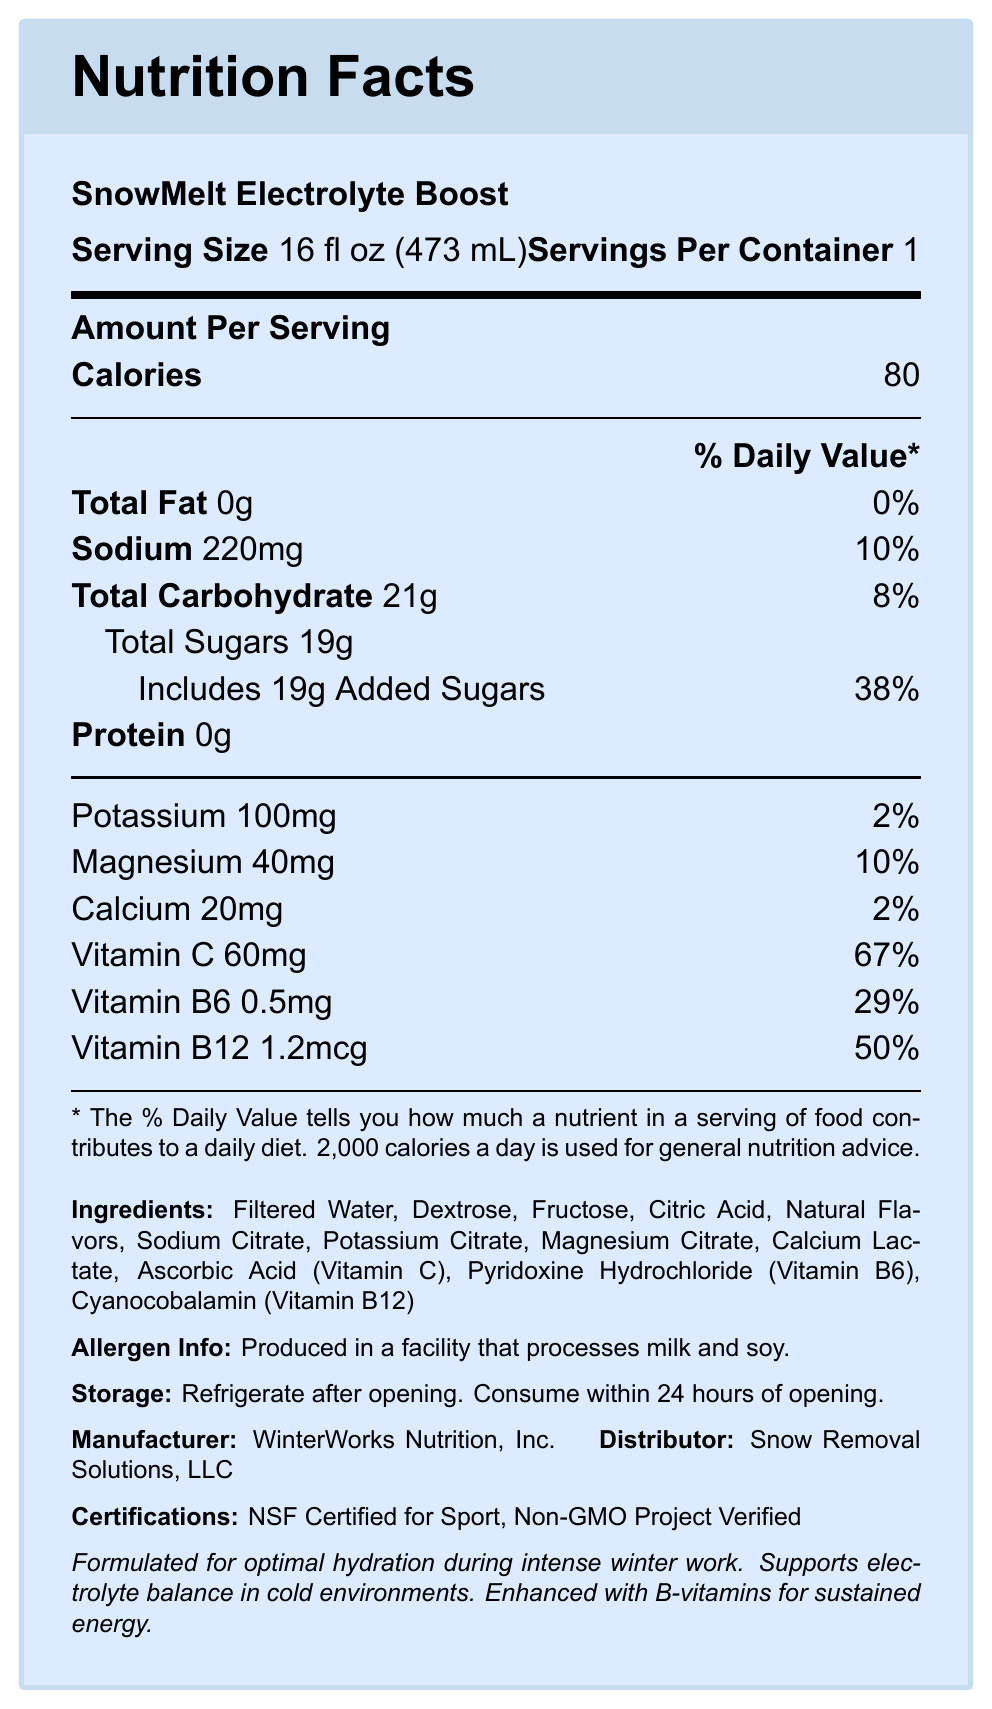What is the serving size of SnowMelt Electrolyte Boost? The document specifies the serving size clearly at the top.
Answer: 16 fl oz (473 mL) How many calories are in one serving? The calories per serving are listed under the "Amount Per Serving" section.
Answer: 80 calories What is the % Daily Value of sodium per serving? The % Daily Value of sodium is given in the same row as the sodium amount, which is 220mg and 10%.
Answer: 10% Which ingredient provides Vitamin C in the drink? The list of ingredients includes Ascorbic Acid which is known as Vitamin C.
Answer: Ascorbic Acid Should the product be refrigerated after opening? The document contains storage instructions specifying to refrigerate after opening.
Answer: Yes How many grams of total sugar does one serving contain? The amount of total sugars per serving is stated as 19g in the nutritional facts.
Answer: 19g What potential allergens might be present due to the processing facility? A. Nuts B. Milk and Soy C. Gluten D. Eggs The allergen information specifies that the product is made in a facility that processes milk and soy.
Answer: B. Milk and Soy Which of the following vitamins is NOT included in the drink? I. Vitamin A II. Vitamin C III. Vitamin B6 IV. Vitamin B12 The nutritional facts label lists Vitamin C, Vitamin B6, and Vitamin B12, but does not include Vitamin A.
Answer: I. Vitamin A Does the drink provide any protein per serving? The nutritional facts state that the protein amount per serving is 0g.
Answer: No Summarize the nutrition and beneficial components of this sports drink. The drink is particularly formulated to support electrolyte balance and sustained energy in cold environments, beneficial for snow removal crews.
Answer: SnowMelt Electrolyte Boost is designed for optimal hydration during intense winter work. A 16 fl oz serving contains 80 calories, 0g of fat, 220mg of sodium (10% DV), 21g of carbohydrates (8% DV), 19g of sugars (including 19g added sugars comprising 38% DV), 100mg of potassium (2% DV), 40mg of magnesium (10% DV), 20mg of calcium (2% DV), 60mg of Vitamin C (67% DV), 0.5mg of Vitamin B6 (29% DV), and 1.2mcg of Vitamin B12 (50% DV). It is NSF Certified for Sport and Non-GMO Project Verified. Ingredients include filtered water, dextrose, and a range of vitamins and minerals. The drink should be refrigerated after opening and consumed within 24 hours. Is this product certified for use in sports? The document indicates that the product is NSF Certified for Sport.
Answer: Yes What is the role of B-vitamins in this drink according to the additional information? The additional information mentions that the B-vitamins are enhanced for sustained energy.
Answer: Sustained energy What is the concentration of Vitamin C per serving? The nutrient details in the document list Vitamin C as 60mg per serving.
Answer: 60mg Who distributes the SnowMelt Electrolyte Boost? The distributor information is provided at the end of the nutritional facts, stating it is Snow Removal Solutions, LLC.
Answer: Snow Removal Solutions, LLC What is the daily value percentage for Magnesium in this sports drink? The % Daily Value of Magnesium is stated as 10% in the nutrient section.
Answer: 10% How should the drink be stored and consumed after opening? The storage instructions specify that it should be refrigerated after opening and consumed within 24 hours.
Answer: Refrigerate after opening. Consume within 24 hours of opening. Can we determine how many bottles come in a pack? The document does not provide any information regarding the number of bottles or packs.
Answer: Not enough information Which company manufactures the SnowMelt Electrolyte Boost? The manufacturer's information is listed as WinterWorks Nutrition, Inc. at the end of the document.
Answer: WinterWorks Nutrition, Inc. 